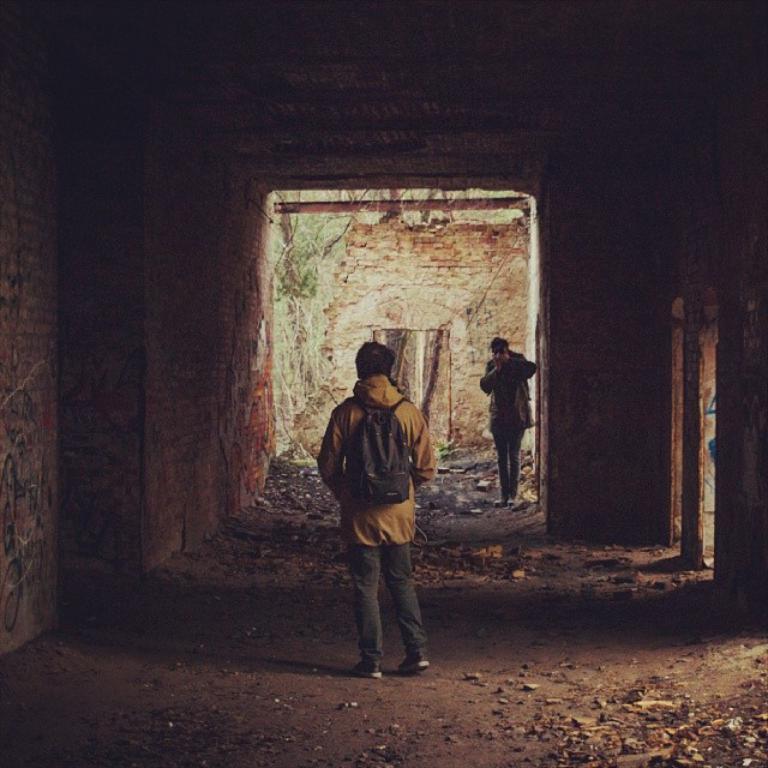Could you give a brief overview of what you see in this image? In this picture we can see few people, in the middle of the image we can see a person and the person wore a bag, in the background we can find few plants. 